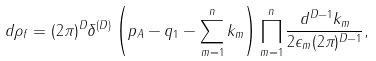Convert formula to latex. <formula><loc_0><loc_0><loc_500><loc_500>d \rho _ { f } = ( 2 \pi ) ^ { D } \delta ^ { ( D ) } \left ( p _ { A } - q _ { 1 } - \sum _ { m = 1 } ^ { n } k _ { m } \right ) \prod _ { m = 1 } ^ { n } \frac { d ^ { D - 1 } k _ { m } } { 2 \epsilon _ { m } ( 2 \pi ) ^ { D - 1 } } ,</formula> 